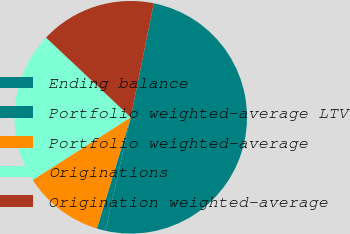<chart> <loc_0><loc_0><loc_500><loc_500><pie_chart><fcel>Ending balance<fcel>Portfolio weighted-average LTV<fcel>Portfolio weighted-average<fcel>Originations<fcel>Origination weighted-average<nl><fcel>50.3%<fcel>1.21%<fcel>11.25%<fcel>21.07%<fcel>16.16%<nl></chart> 